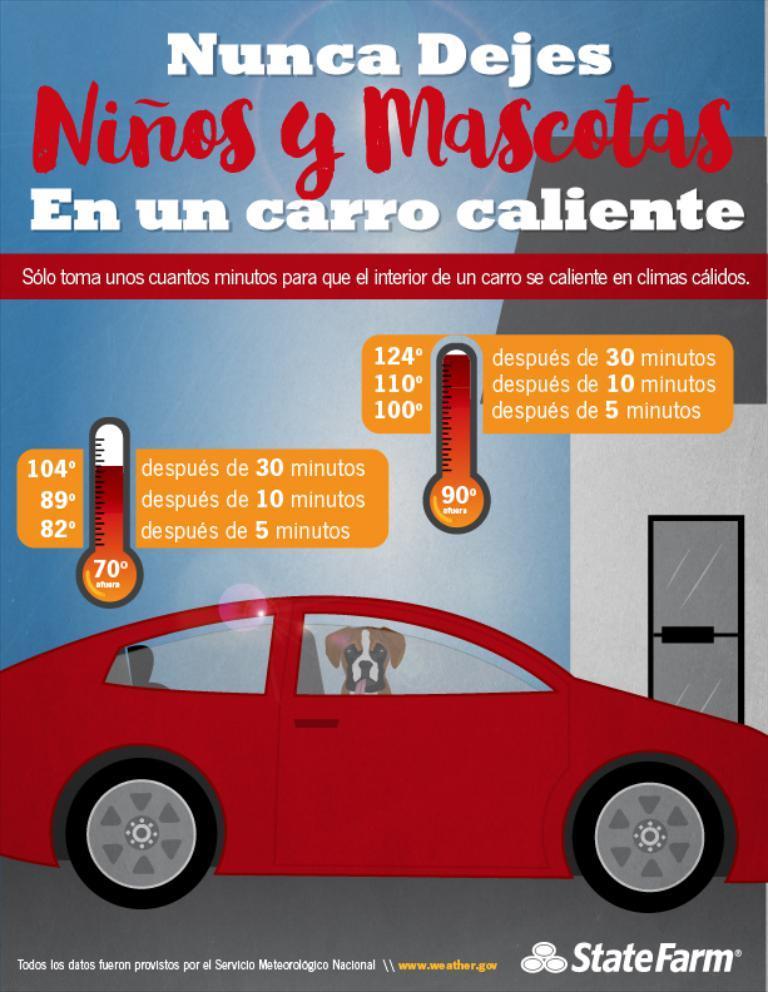Describe this image in one or two sentences. We can see poster,on this poster we can see a dog inside a car and we can see text. 